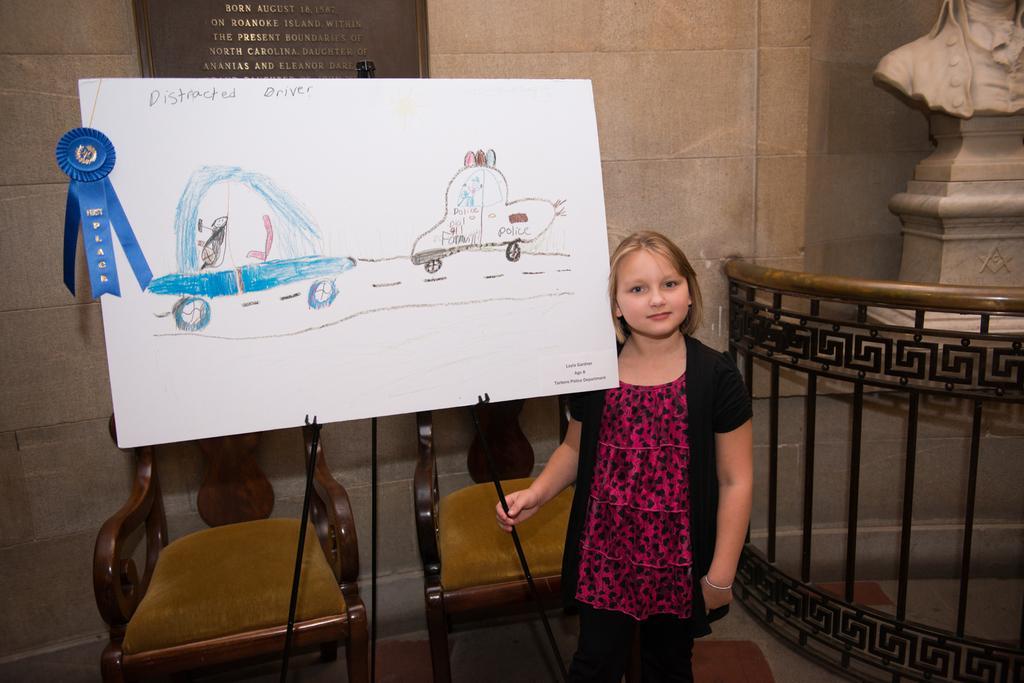Please provide a concise description of this image. This is the picture of a little girl who is standing near the note stand to which there is some blue color ribbon passed to it and behind there are two chairs. 